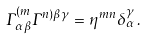<formula> <loc_0><loc_0><loc_500><loc_500>\Gamma ^ { ( m } _ { \alpha \beta } \Gamma ^ { n ) \beta \gamma } = \eta ^ { m n } \delta _ { \alpha } ^ { \gamma } \, .</formula> 